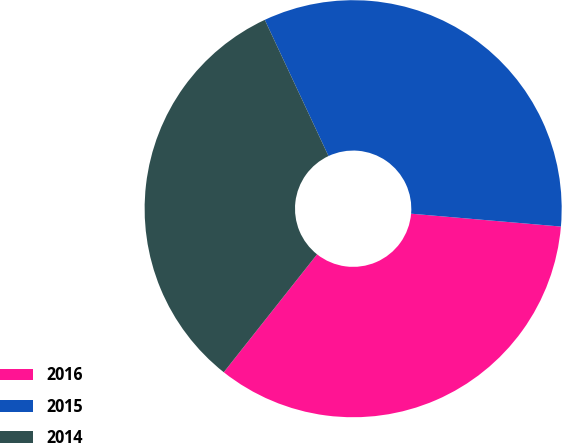<chart> <loc_0><loc_0><loc_500><loc_500><pie_chart><fcel>2016<fcel>2015<fcel>2014<nl><fcel>34.29%<fcel>33.33%<fcel>32.38%<nl></chart> 